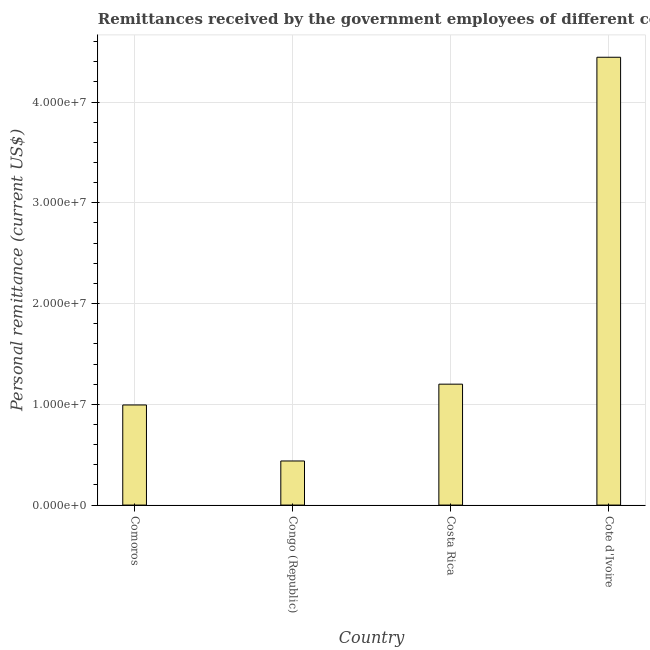Does the graph contain grids?
Your answer should be compact. Yes. What is the title of the graph?
Provide a short and direct response. Remittances received by the government employees of different countries in 1990. What is the label or title of the Y-axis?
Your answer should be very brief. Personal remittance (current US$). What is the personal remittances in Cote d'Ivoire?
Your answer should be compact. 4.44e+07. Across all countries, what is the maximum personal remittances?
Your answer should be very brief. 4.44e+07. Across all countries, what is the minimum personal remittances?
Your answer should be compact. 4.38e+06. In which country was the personal remittances maximum?
Ensure brevity in your answer.  Cote d'Ivoire. In which country was the personal remittances minimum?
Give a very brief answer. Congo (Republic). What is the sum of the personal remittances?
Keep it short and to the point. 7.08e+07. What is the difference between the personal remittances in Comoros and Congo (Republic)?
Provide a succinct answer. 5.56e+06. What is the average personal remittances per country?
Your response must be concise. 1.77e+07. What is the median personal remittances?
Your response must be concise. 1.10e+07. In how many countries, is the personal remittances greater than 14000000 US$?
Offer a very short reply. 1. What is the ratio of the personal remittances in Comoros to that in Congo (Republic)?
Keep it short and to the point. 2.27. Is the personal remittances in Comoros less than that in Congo (Republic)?
Offer a very short reply. No. Is the difference between the personal remittances in Comoros and Cote d'Ivoire greater than the difference between any two countries?
Keep it short and to the point. No. What is the difference between the highest and the second highest personal remittances?
Offer a very short reply. 3.24e+07. Is the sum of the personal remittances in Comoros and Congo (Republic) greater than the maximum personal remittances across all countries?
Ensure brevity in your answer.  No. What is the difference between the highest and the lowest personal remittances?
Your response must be concise. 4.01e+07. How many bars are there?
Your response must be concise. 4. Are the values on the major ticks of Y-axis written in scientific E-notation?
Offer a very short reply. Yes. What is the Personal remittance (current US$) in Comoros?
Offer a very short reply. 9.94e+06. What is the Personal remittance (current US$) of Congo (Republic)?
Your answer should be compact. 4.38e+06. What is the Personal remittance (current US$) of Cote d'Ivoire?
Your response must be concise. 4.44e+07. What is the difference between the Personal remittance (current US$) in Comoros and Congo (Republic)?
Make the answer very short. 5.56e+06. What is the difference between the Personal remittance (current US$) in Comoros and Costa Rica?
Give a very brief answer. -2.06e+06. What is the difference between the Personal remittance (current US$) in Comoros and Cote d'Ivoire?
Provide a succinct answer. -3.45e+07. What is the difference between the Personal remittance (current US$) in Congo (Republic) and Costa Rica?
Give a very brief answer. -7.62e+06. What is the difference between the Personal remittance (current US$) in Congo (Republic) and Cote d'Ivoire?
Keep it short and to the point. -4.01e+07. What is the difference between the Personal remittance (current US$) in Costa Rica and Cote d'Ivoire?
Your response must be concise. -3.24e+07. What is the ratio of the Personal remittance (current US$) in Comoros to that in Congo (Republic)?
Offer a terse response. 2.27. What is the ratio of the Personal remittance (current US$) in Comoros to that in Costa Rica?
Your answer should be compact. 0.83. What is the ratio of the Personal remittance (current US$) in Comoros to that in Cote d'Ivoire?
Offer a very short reply. 0.22. What is the ratio of the Personal remittance (current US$) in Congo (Republic) to that in Costa Rica?
Your response must be concise. 0.36. What is the ratio of the Personal remittance (current US$) in Congo (Republic) to that in Cote d'Ivoire?
Keep it short and to the point. 0.1. What is the ratio of the Personal remittance (current US$) in Costa Rica to that in Cote d'Ivoire?
Give a very brief answer. 0.27. 